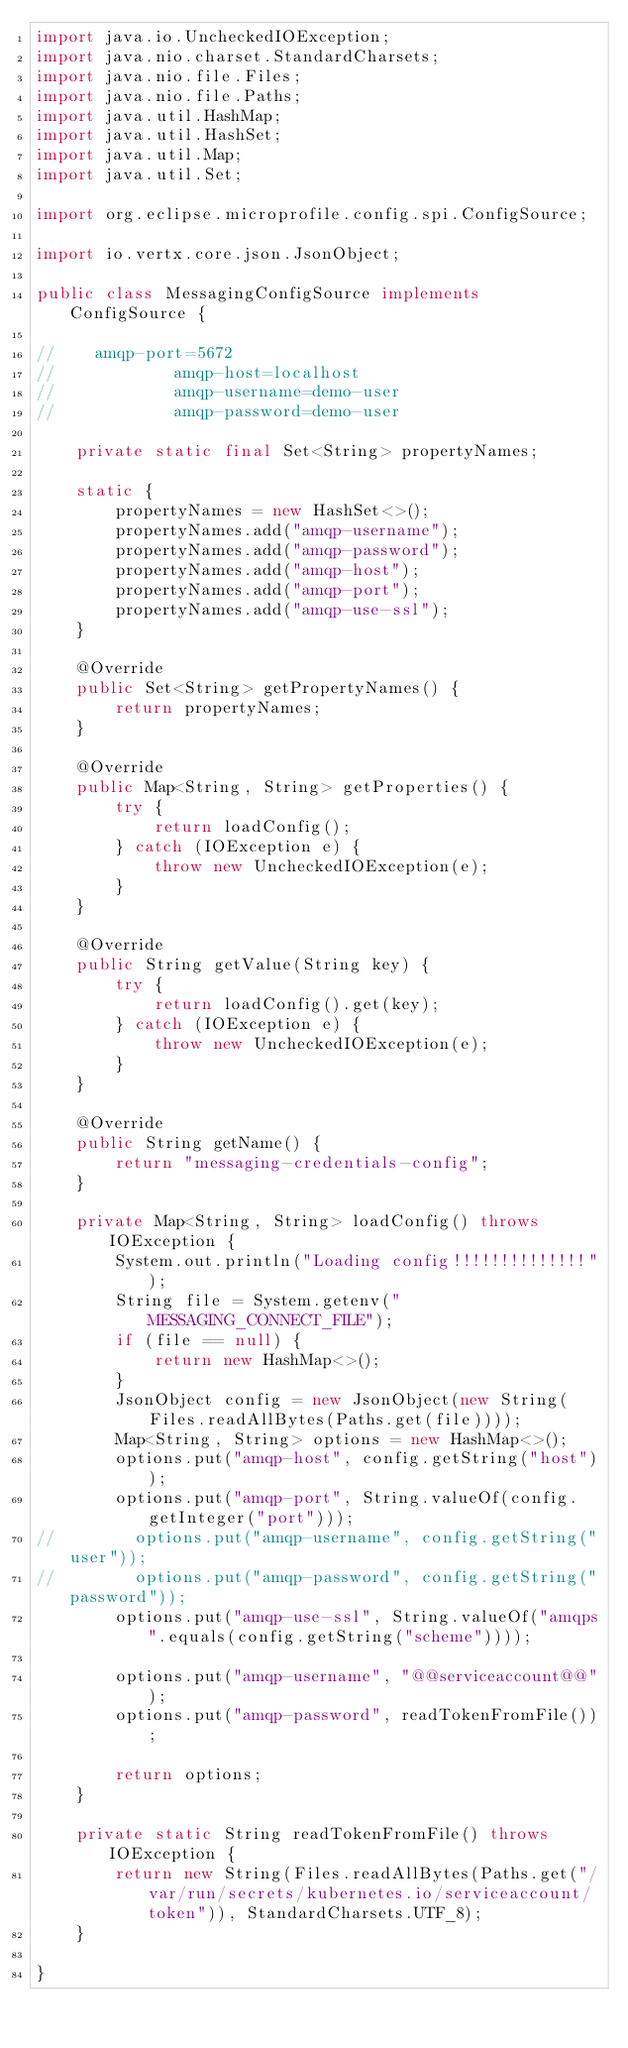<code> <loc_0><loc_0><loc_500><loc_500><_Java_>import java.io.UncheckedIOException;
import java.nio.charset.StandardCharsets;
import java.nio.file.Files;
import java.nio.file.Paths;
import java.util.HashMap;
import java.util.HashSet;
import java.util.Map;
import java.util.Set;

import org.eclipse.microprofile.config.spi.ConfigSource;

import io.vertx.core.json.JsonObject;

public class MessagingConfigSource implements ConfigSource {

//    amqp-port=5672
//            amqp-host=localhost
//            amqp-username=demo-user
//            amqp-password=demo-user

    private static final Set<String> propertyNames;

    static {
        propertyNames = new HashSet<>();
        propertyNames.add("amqp-username");
        propertyNames.add("amqp-password");
        propertyNames.add("amqp-host");
        propertyNames.add("amqp-port");
        propertyNames.add("amqp-use-ssl");
    }

    @Override
    public Set<String> getPropertyNames() {
        return propertyNames;
    }

    @Override
    public Map<String, String> getProperties() {
        try {
            return loadConfig();
        } catch (IOException e) {
            throw new UncheckedIOException(e);
        }
    }

    @Override
    public String getValue(String key) {
        try {
            return loadConfig().get(key);
        } catch (IOException e) {
            throw new UncheckedIOException(e);
        }
    }

    @Override
    public String getName() {
        return "messaging-credentials-config";
    }

    private Map<String, String> loadConfig() throws IOException {
        System.out.println("Loading config!!!!!!!!!!!!!!");
        String file = System.getenv("MESSAGING_CONNECT_FILE");
        if (file == null) {
            return new HashMap<>();
        }
        JsonObject config = new JsonObject(new String(Files.readAllBytes(Paths.get(file))));
        Map<String, String> options = new HashMap<>();
        options.put("amqp-host", config.getString("host"));
        options.put("amqp-port", String.valueOf(config.getInteger("port")));
//        options.put("amqp-username", config.getString("user"));
//        options.put("amqp-password", config.getString("password"));
        options.put("amqp-use-ssl", String.valueOf("amqps".equals(config.getString("scheme"))));

        options.put("amqp-username", "@@serviceaccount@@");
        options.put("amqp-password", readTokenFromFile());

        return options;
    }

    private static String readTokenFromFile() throws IOException {
        return new String(Files.readAllBytes(Paths.get("/var/run/secrets/kubernetes.io/serviceaccount/token")), StandardCharsets.UTF_8);
    }

}
</code> 